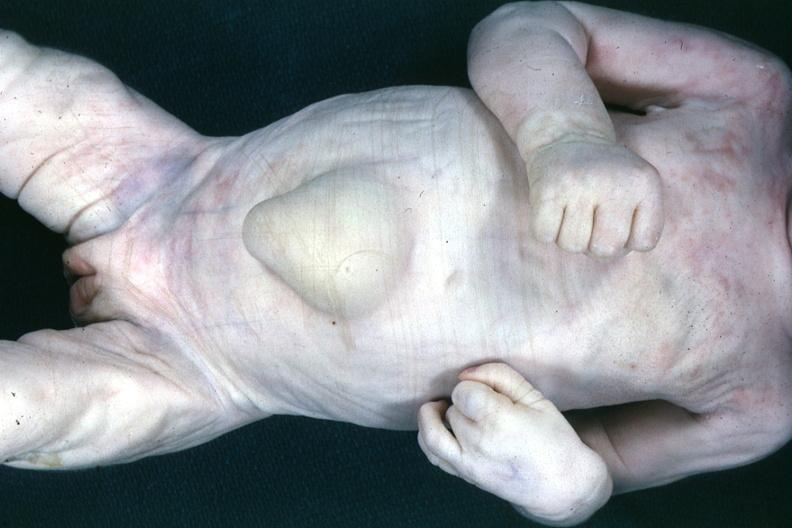what does this image show?
Answer the question using a single word or phrase. Good example of large umbilical hernia 